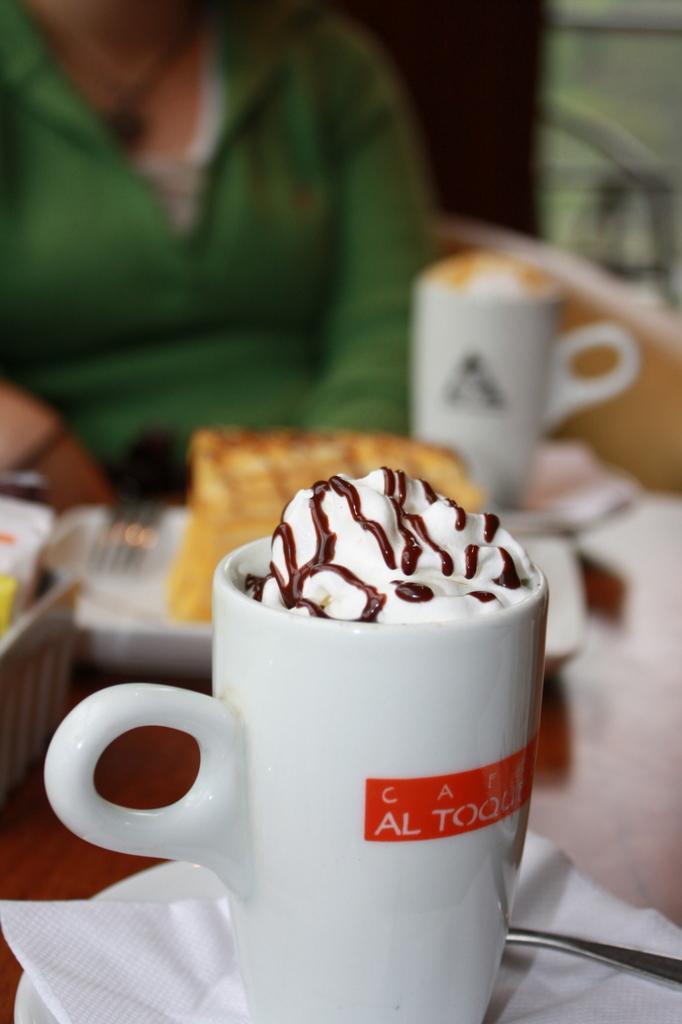How would you summarize this image in a sentence or two? In this picture there is a person sitting. In the foreground there are cups and there is a plate and bowl and there are saucers on the table and there is food on the plate and in the cups and there is a fork. At the back there is a chair. 